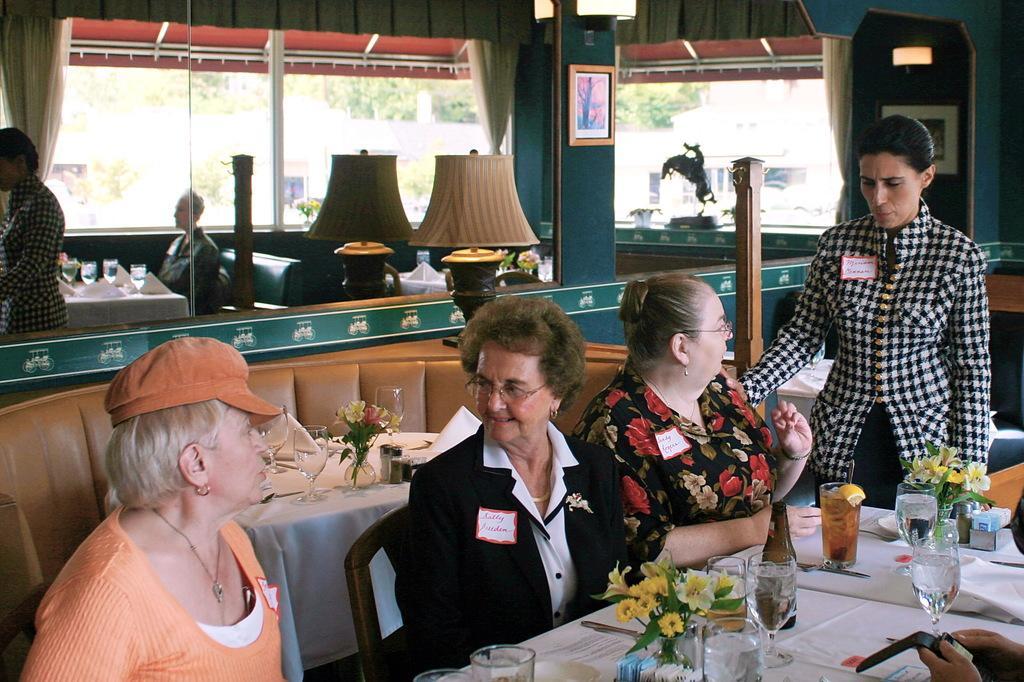Describe this image in one or two sentences. This is a restaurant. Here we can see photo frames. This is a light. We can see few persons sitting on chairs in front of a table and on the table we can see water glasses, tissue papers, flower vase, bottles, juice in a glass. We can two persons standing in a picture. These are lights. Through window glass we can see trees. 